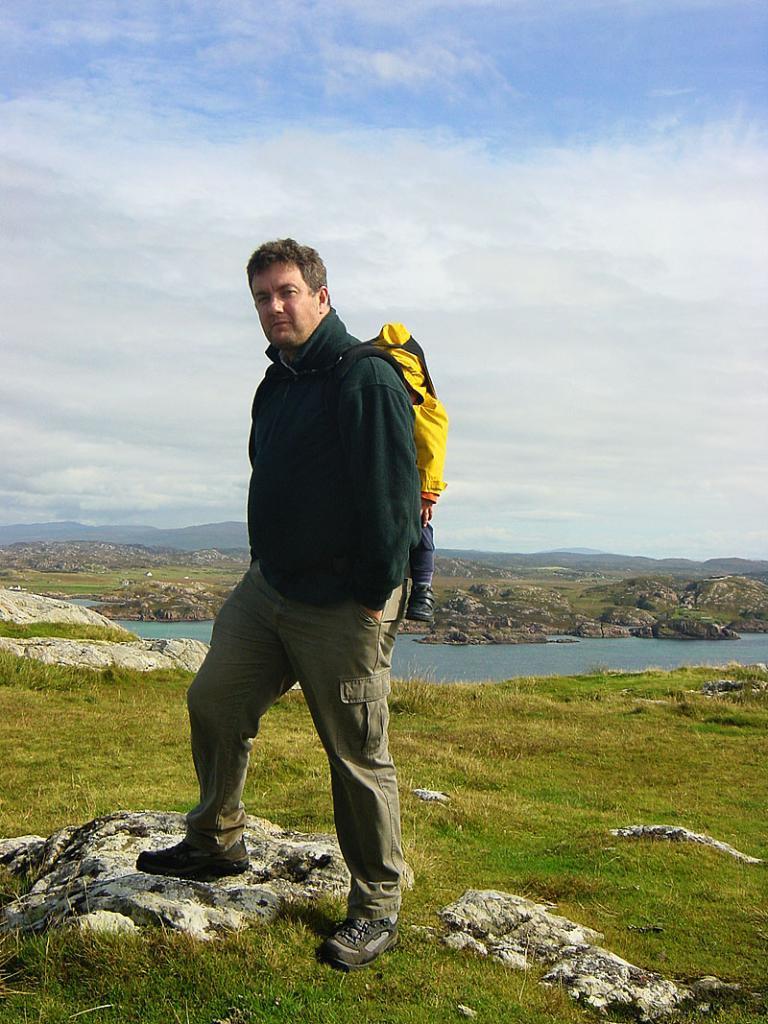How would you summarize this image in a sentence or two? In this image I can see the person standing and the person is wearing black and brown color dress. Background I can see the grass and trees in green color and I can also see the water and the sky is in blue and white color. 